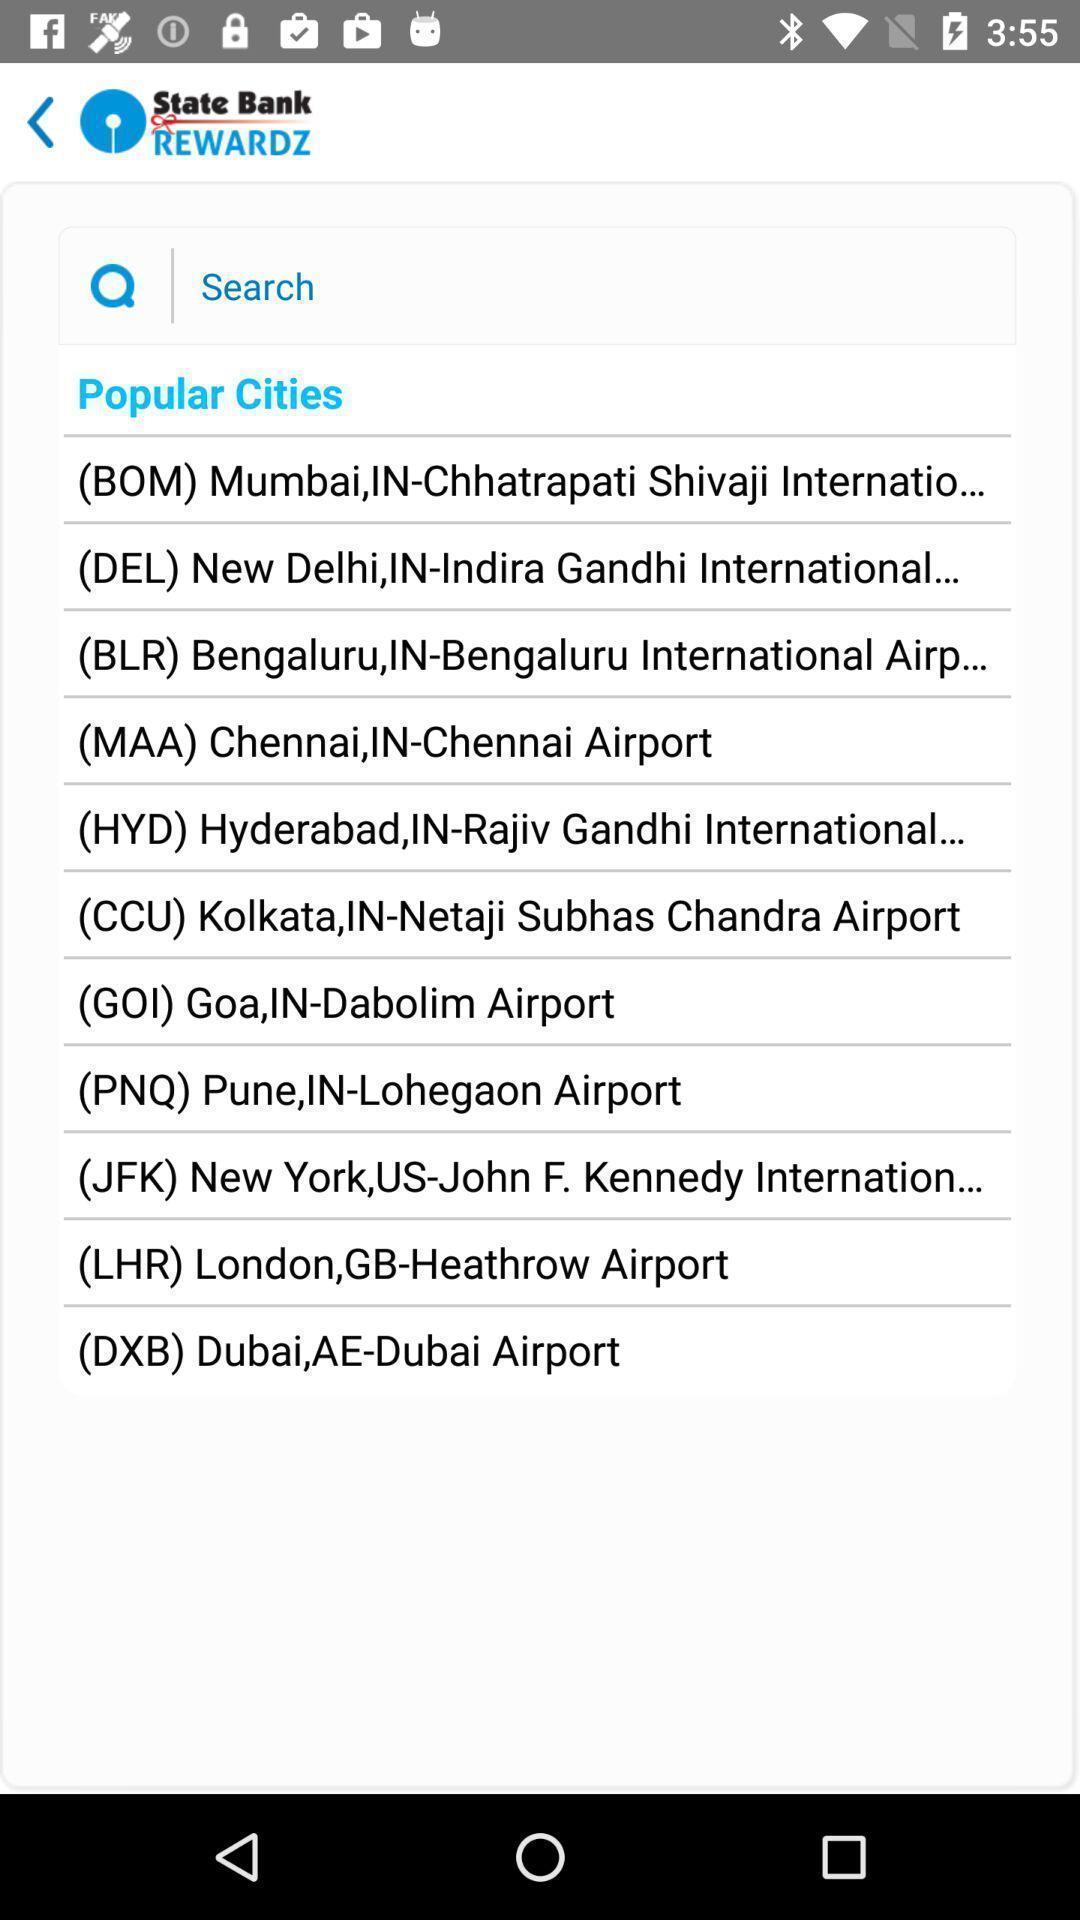Summarize the main components in this picture. Search page for searching of popular cities. 